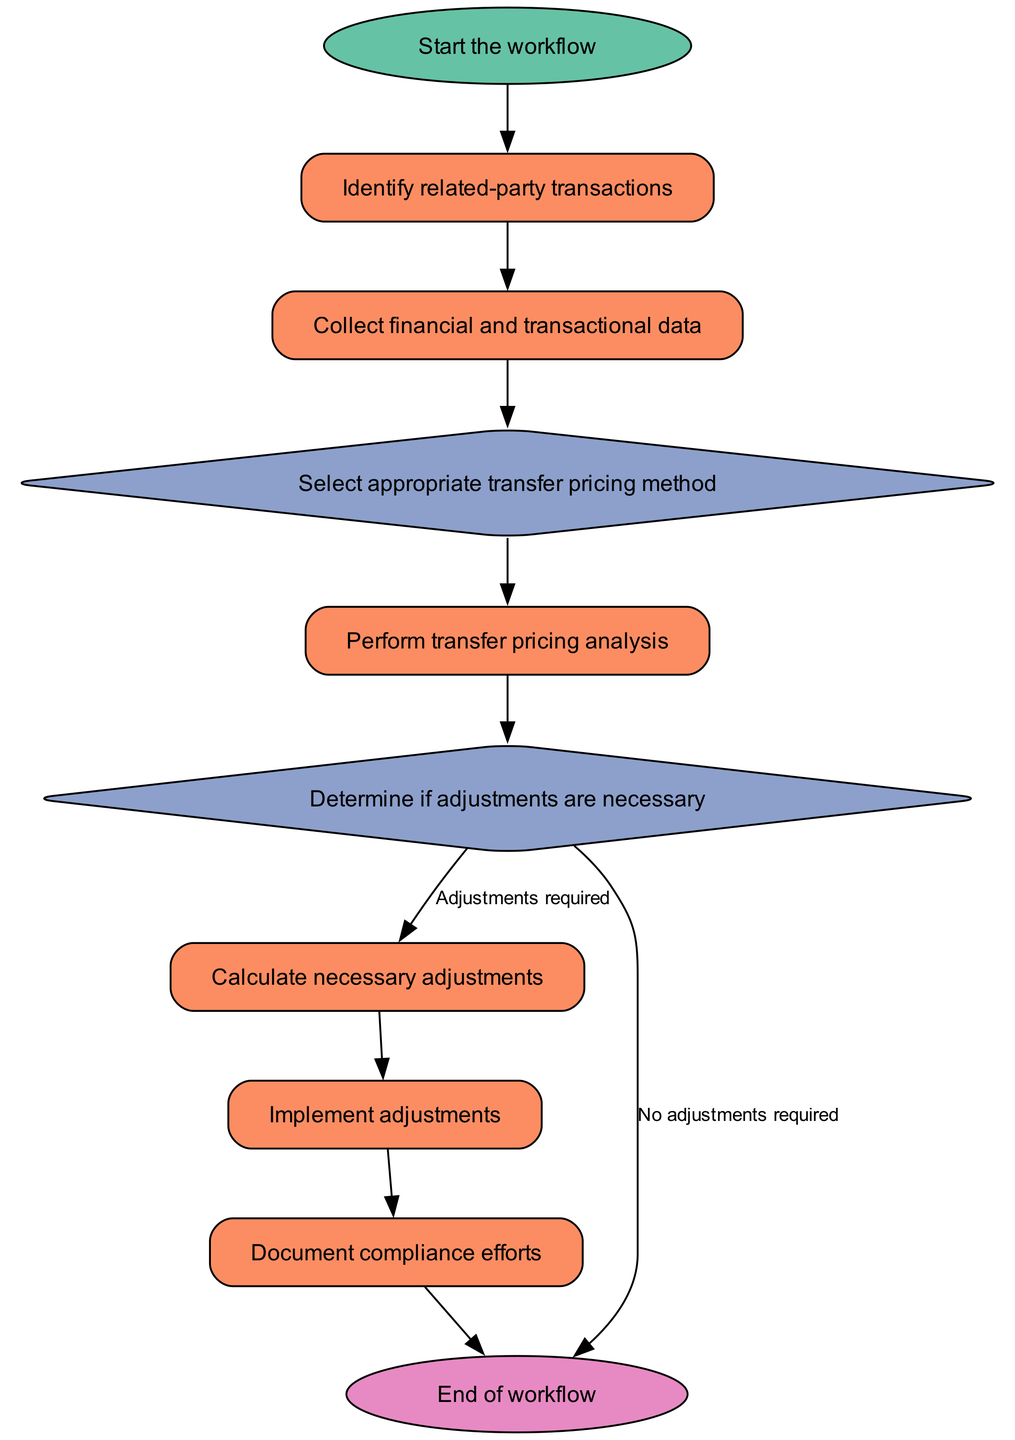What is the first step in the workflow? The first node in the workflow diagram is labeled "Start the workflow." This indicates that the process begins with this step.
Answer: Start the workflow How many decision nodes are there in the workflow? By reviewing the flowchart, there are two decision nodes: "Select appropriate transfer pricing method" and "Determine if adjustments are necessary." Therefore, the count is two.
Answer: Two What follows after "Collect financial and transactional data"? The node immediately following "Collect financial and transactional data" is "Select appropriate transfer pricing method." This shows the sequential flow of the process.
Answer: Select appropriate transfer pricing method If adjustments are required, what is the next step after determining adjustments? When adjustments are required, the workflow directs to "Calculate necessary adjustments," which is the next action to be taken.
Answer: Calculate necessary adjustments What is the final step in the workflow? The last node in the workflow is labeled "End of workflow," signifying the conclusion of the entire process.
Answer: End of workflow What are the options available for the transfer pricing method selection? The options provided in the "Select appropriate transfer pricing method" decision node include: Comparable Uncontrolled Price, Resale Price Method, Cost Plus Method, Transactional Net Margin Method, and Profit Split Method.
Answer: Comparable Uncontrolled Price, Resale Price Method, Cost Plus Method, Transactional Net Margin Method, Profit Split Method What happens if no adjustments are required? If no adjustments are needed, the workflow leads directly to the "End of workflow" node, thus concluding the process without further actions.
Answer: End of workflow How does the workflow ensure documentation of compliance efforts? After implementing adjustments, the workflow proceeds to "Document compliance efforts," which ensures that all actions taken are well-documented as part of the compliance process.
Answer: Document compliance efforts 